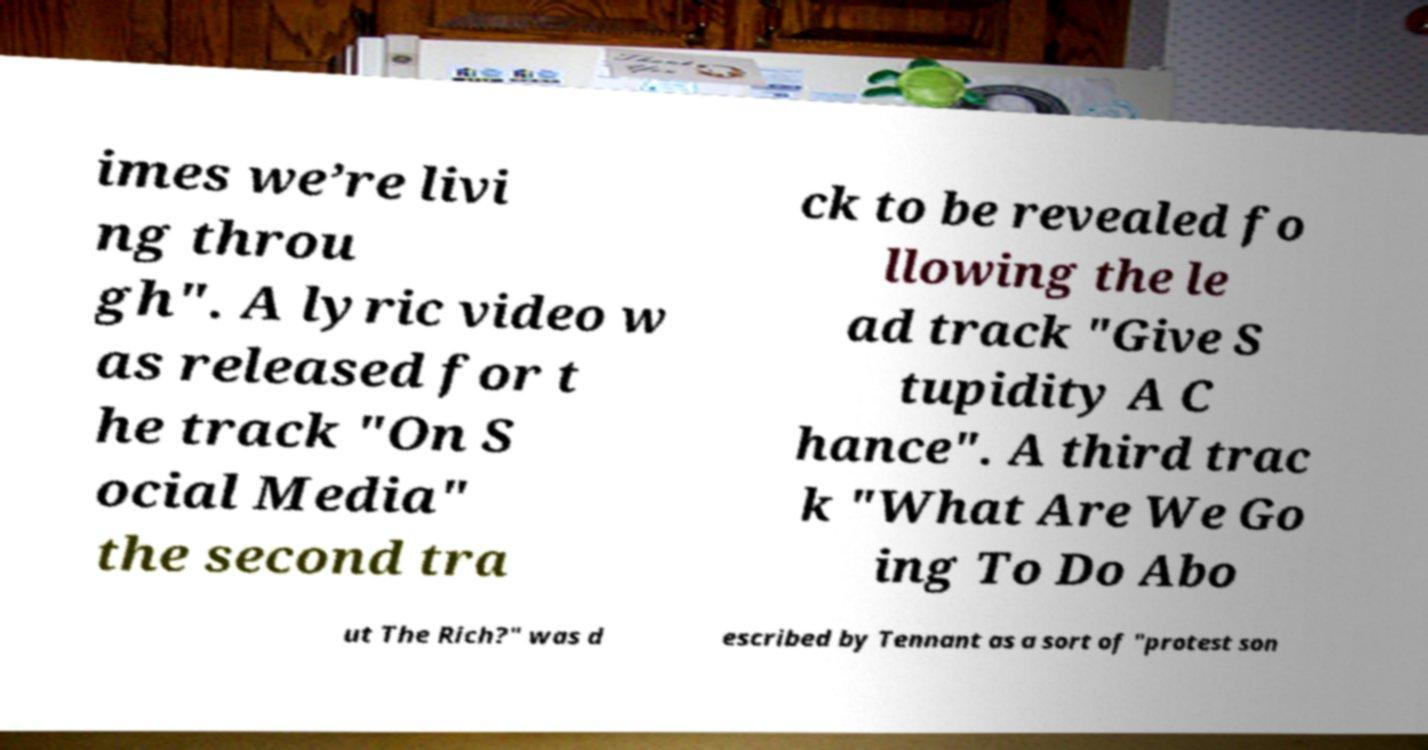There's text embedded in this image that I need extracted. Can you transcribe it verbatim? imes we’re livi ng throu gh". A lyric video w as released for t he track "On S ocial Media" the second tra ck to be revealed fo llowing the le ad track "Give S tupidity A C hance". A third trac k "What Are We Go ing To Do Abo ut The Rich?" was d escribed by Tennant as a sort of "protest son 